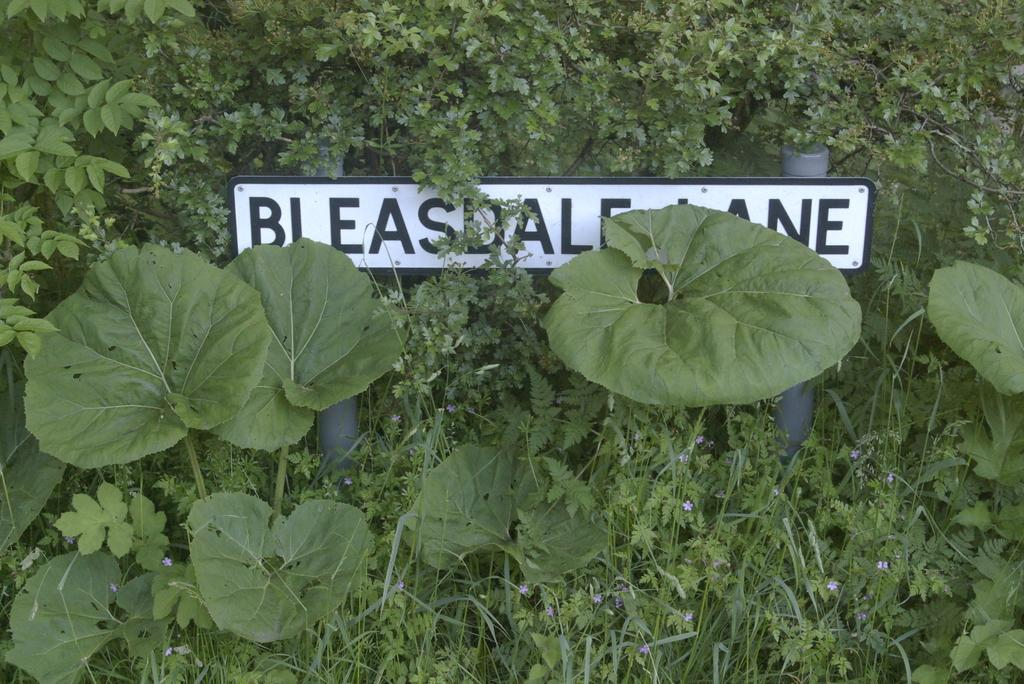What is the main object in the middle of the image? There is a sign board in the middle of the image. What can be seen in the background of the image? There are plants in the background of the image. How much oil is required to rub on the plants in the image? There is no mention of oil or rubbing on the plants in the image. The image only shows a sign board and plants in the background. 